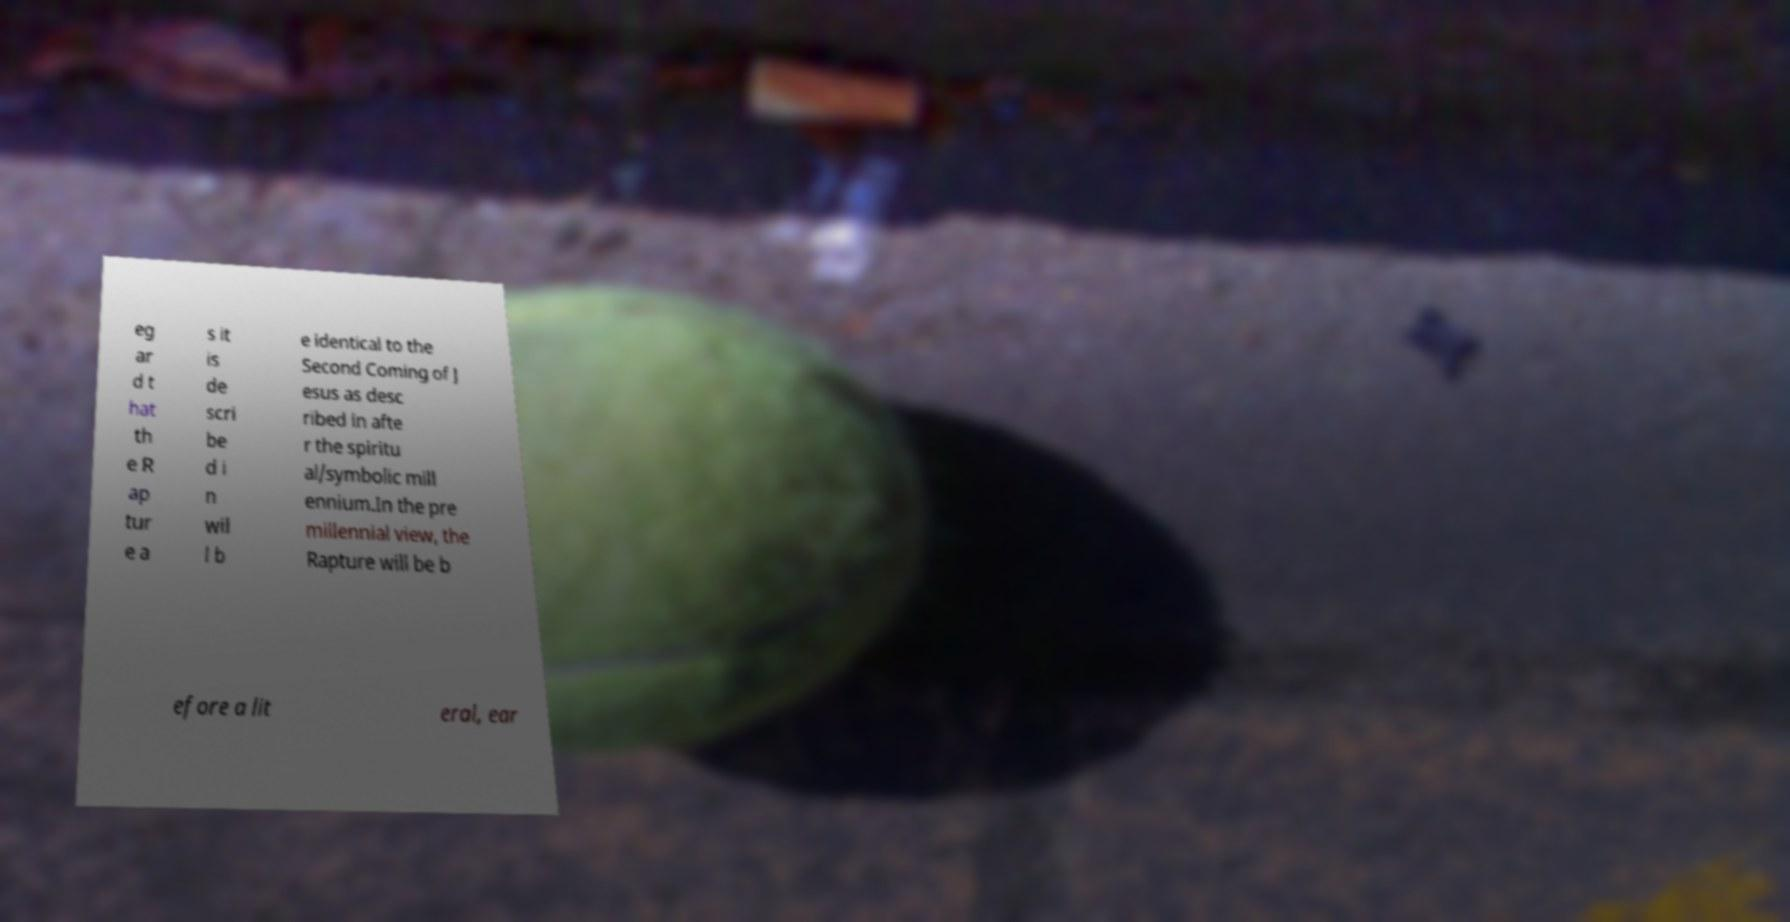Could you assist in decoding the text presented in this image and type it out clearly? eg ar d t hat th e R ap tur e a s it is de scri be d i n wil l b e identical to the Second Coming of J esus as desc ribed in afte r the spiritu al/symbolic mill ennium.In the pre millennial view, the Rapture will be b efore a lit eral, ear 